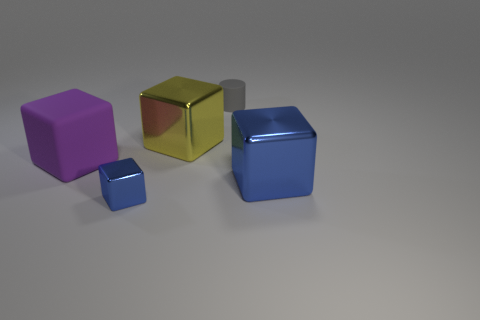Add 5 large matte objects. How many objects exist? 10 Subtract all big purple cubes. How many cubes are left? 3 Subtract all yellow blocks. How many blocks are left? 3 Add 3 big blue metallic cubes. How many big blue metallic cubes exist? 4 Subtract 0 purple cylinders. How many objects are left? 5 Subtract all cylinders. How many objects are left? 4 Subtract all red cubes. Subtract all brown cylinders. How many cubes are left? 4 Subtract all gray balls. How many yellow cubes are left? 1 Subtract all rubber things. Subtract all large green shiny blocks. How many objects are left? 3 Add 2 small gray matte cylinders. How many small gray matte cylinders are left? 3 